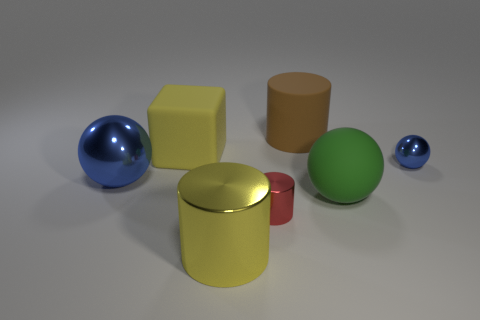Subtract all big cylinders. How many cylinders are left? 1 Add 3 brown matte cylinders. How many objects exist? 10 Subtract all yellow cylinders. How many cylinders are left? 2 Subtract all blue cylinders. How many blue balls are left? 2 Subtract 1 blocks. How many blocks are left? 0 Subtract all spheres. How many objects are left? 4 Add 6 small red blocks. How many small red blocks exist? 6 Subtract 0 cyan balls. How many objects are left? 7 Subtract all cyan balls. Subtract all green cylinders. How many balls are left? 3 Subtract all blue rubber objects. Subtract all big yellow matte objects. How many objects are left? 6 